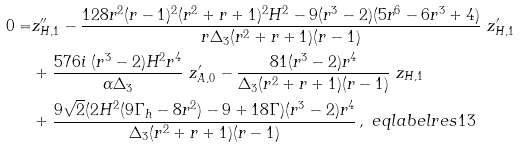Convert formula to latex. <formula><loc_0><loc_0><loc_500><loc_500>0 = & z _ { H , 1 } ^ { \prime \prime } - \frac { 1 2 8 r ^ { 2 } ( r - 1 ) ^ { 2 } ( r ^ { 2 } + r + 1 ) ^ { 2 } H ^ { 2 } - 9 ( r ^ { 3 } - 2 ) ( 5 r ^ { 6 } - 6 r ^ { 3 } + 4 ) } { r \Delta _ { 3 } ( r ^ { 2 } + r + 1 ) ( r - 1 ) } \ z _ { H , 1 } ^ { \prime } \\ & + \frac { 5 7 6 i \ ( r ^ { 3 } - 2 ) H ^ { 2 } r ^ { 4 } } { \alpha \Delta _ { 3 } } \ z _ { A , 0 } ^ { \prime } - \frac { 8 1 ( r ^ { 3 } - 2 ) r ^ { 4 } } { \Delta _ { 3 } ( r ^ { 2 } + r + 1 ) ( r - 1 ) } \ z _ { H , 1 } \\ & + \frac { 9 \sqrt { 2 } ( 2 H ^ { 2 } ( 9 \Gamma _ { h } - 8 r ^ { 2 } ) - 9 + 1 8 \Gamma ) ( r ^ { 3 } - 2 ) r ^ { 4 } } { \Delta _ { 3 } ( r ^ { 2 } + r + 1 ) ( r - 1 ) } \, , \ e q l a b e l { r e s 1 3 }</formula> 